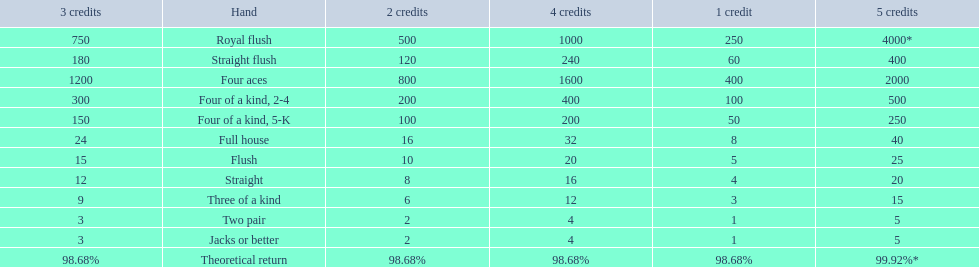What are the different hands? Royal flush, Straight flush, Four aces, Four of a kind, 2-4, Four of a kind, 5-K, Full house, Flush, Straight, Three of a kind, Two pair, Jacks or better. Which hands have a higher standing than a straight? Royal flush, Straight flush, Four aces, Four of a kind, 2-4, Four of a kind, 5-K, Full house, Flush. Of these, which hand is the next highest after a straight? Flush. 